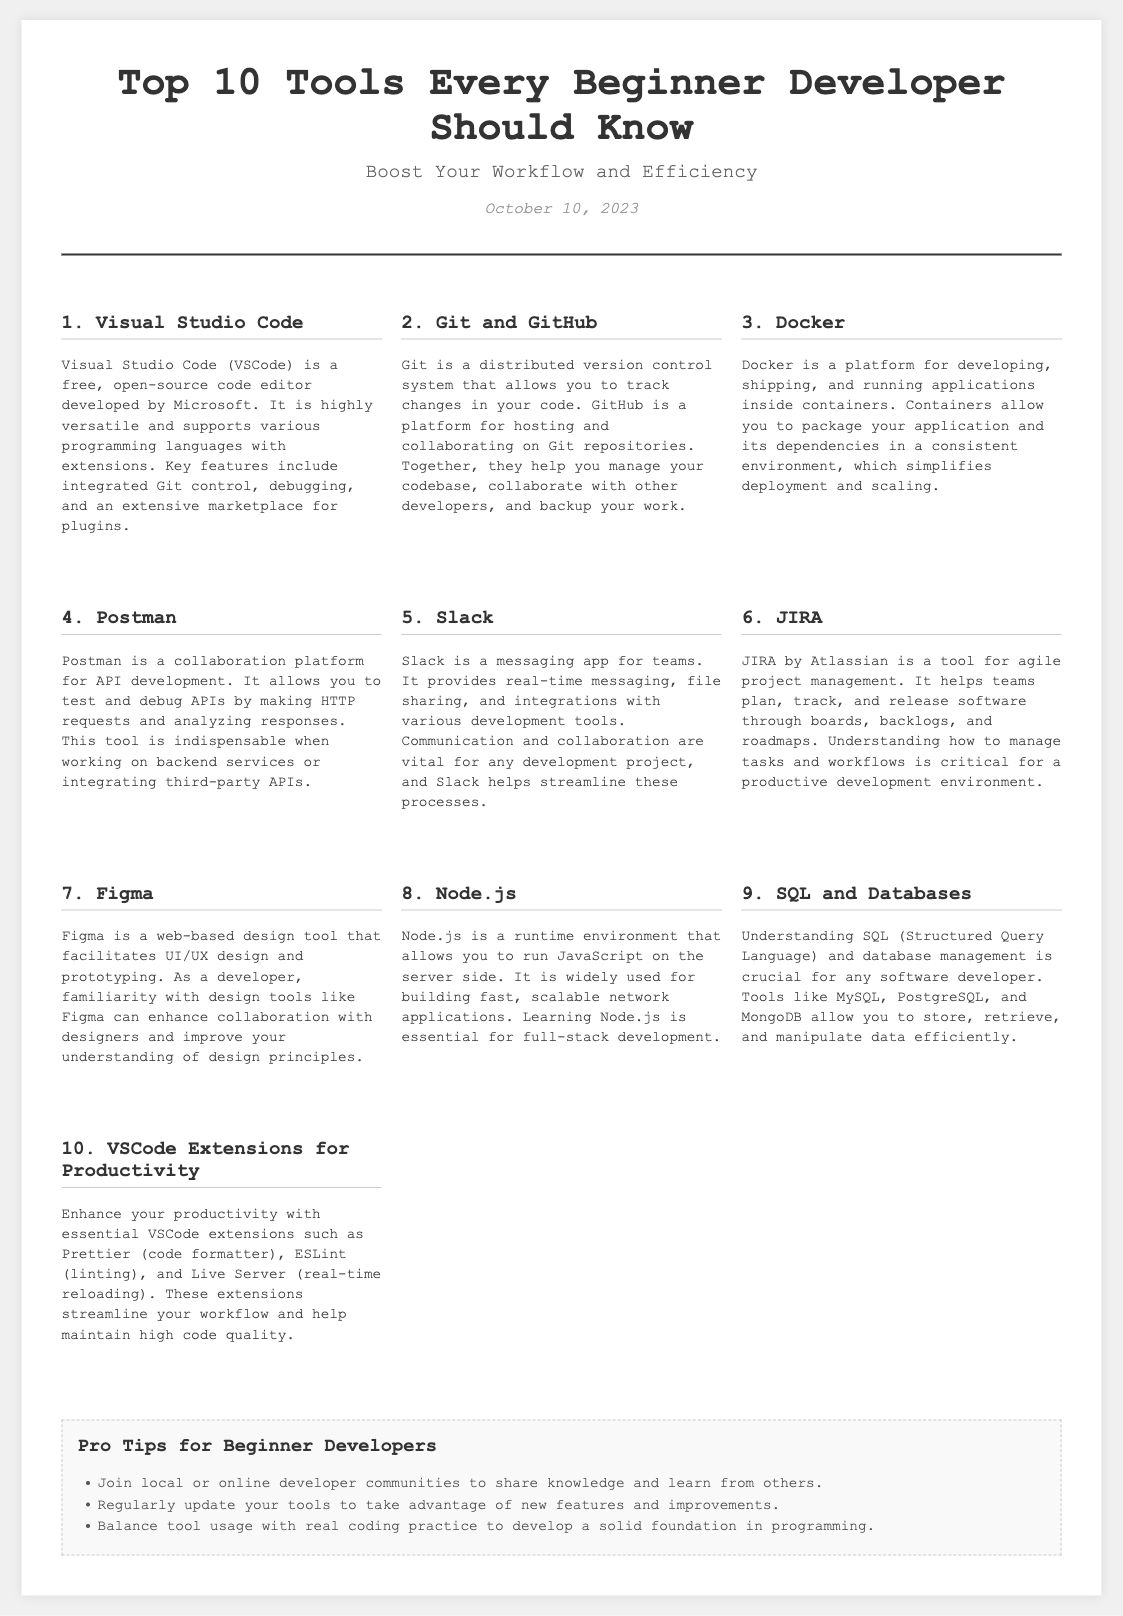What is the title of the document? The title can be found in the header section of the document.
Answer: Top 10 Tools Every Beginner Developer Should Know What is the subtitle of the document? The subtitle is located just below the title in the header section.
Answer: Boost Your Workflow and Efficiency When was the document published? The publication date is mentioned in the date section of the header.
Answer: October 10, 2023 What tool is ranked number 1? The ranking of tools is listed in order in the document's sections.
Answer: Visual Studio Code What is Docker used for? The document describes Docker in the section dedicated to it.
Answer: Developing, shipping, and running applications inside containers How many tools are listed in the document? The document explicitly states the number of tools in the title.
Answer: 10 Which tool is mentioned for API development? The reference to the tool for API development is found in its corresponding section.
Answer: Postman What is a collaboration platform mentioned in the document? The document has a section that introduces a messaging application for teams.
Answer: Slack Which programming language runtime is discussed in the document? The related section specifies the runtime environment covered.
Answer: JavaScript What are two examples of database management tools? The relevant section lists tools associated with database management.
Answer: MySQL, PostgreSQL 